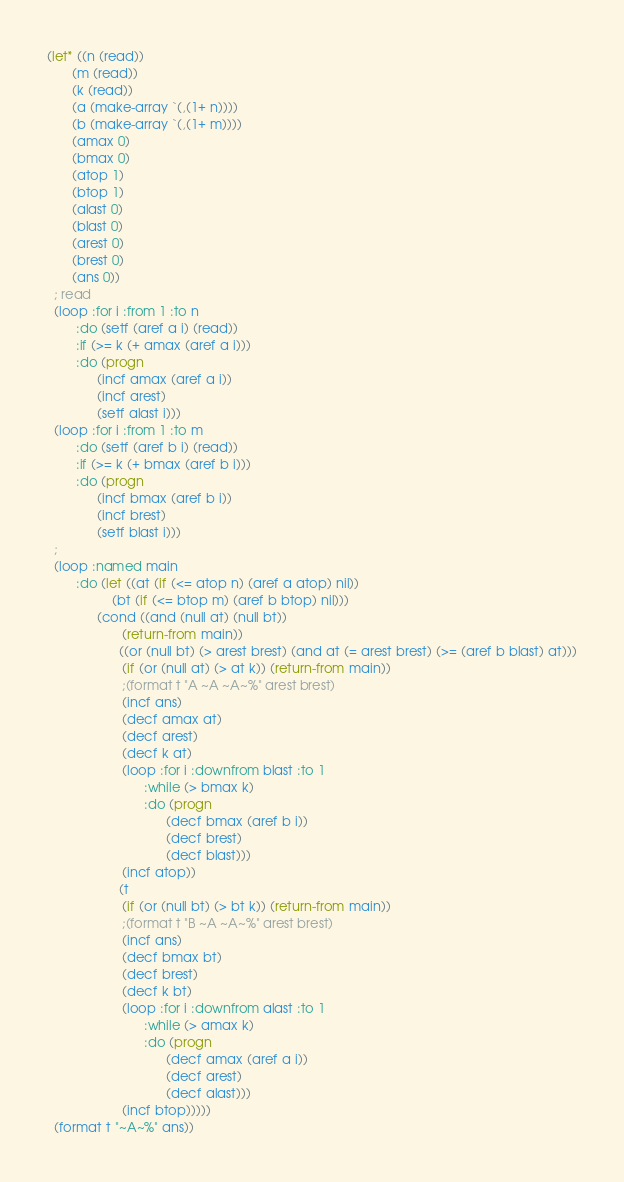<code> <loc_0><loc_0><loc_500><loc_500><_Lisp_>(let* ((n (read))
       (m (read))
       (k (read))
       (a (make-array `(,(1+ n))))
       (b (make-array `(,(1+ m))))
       (amax 0)
       (bmax 0)
       (atop 1)
       (btop 1)
       (alast 0)
       (blast 0)
       (arest 0)
       (brest 0)
       (ans 0))
  ; read
  (loop :for i :from 1 :to n
        :do (setf (aref a i) (read))
        :if (>= k (+ amax (aref a i)))
        :do (progn
              (incf amax (aref a i))
              (incf arest)
              (setf alast i)))
  (loop :for i :from 1 :to m
        :do (setf (aref b i) (read))
        :if (>= k (+ bmax (aref b i)))
        :do (progn
              (incf bmax (aref b i))
              (incf brest)
              (setf blast i)))
  ;
  (loop :named main
        :do (let ((at (if (<= atop n) (aref a atop) nil))
                  (bt (if (<= btop m) (aref b btop) nil)))
              (cond ((and (null at) (null bt))
                     (return-from main))
                    ((or (null bt) (> arest brest) (and at (= arest brest) (>= (aref b blast) at)))
                     (if (or (null at) (> at k)) (return-from main))
                     ;(format t "A ~A ~A~%" arest brest)
                     (incf ans)
                     (decf amax at)
                     (decf arest)
                     (decf k at)
                     (loop :for i :downfrom blast :to 1
                           :while (> bmax k)
                           :do (progn
                                 (decf bmax (aref b i))
                                 (decf brest)
                                 (decf blast)))
                     (incf atop))
                    (t
                     (if (or (null bt) (> bt k)) (return-from main))
                     ;(format t "B ~A ~A~%" arest brest)
                     (incf ans)
                     (decf bmax bt)
                     (decf brest)
                     (decf k bt)
                     (loop :for i :downfrom alast :to 1
                           :while (> amax k)
                           :do (progn
                                 (decf amax (aref a i))
                                 (decf arest)
                                 (decf alast)))
                     (incf btop)))))
  (format t "~A~%" ans))
</code> 